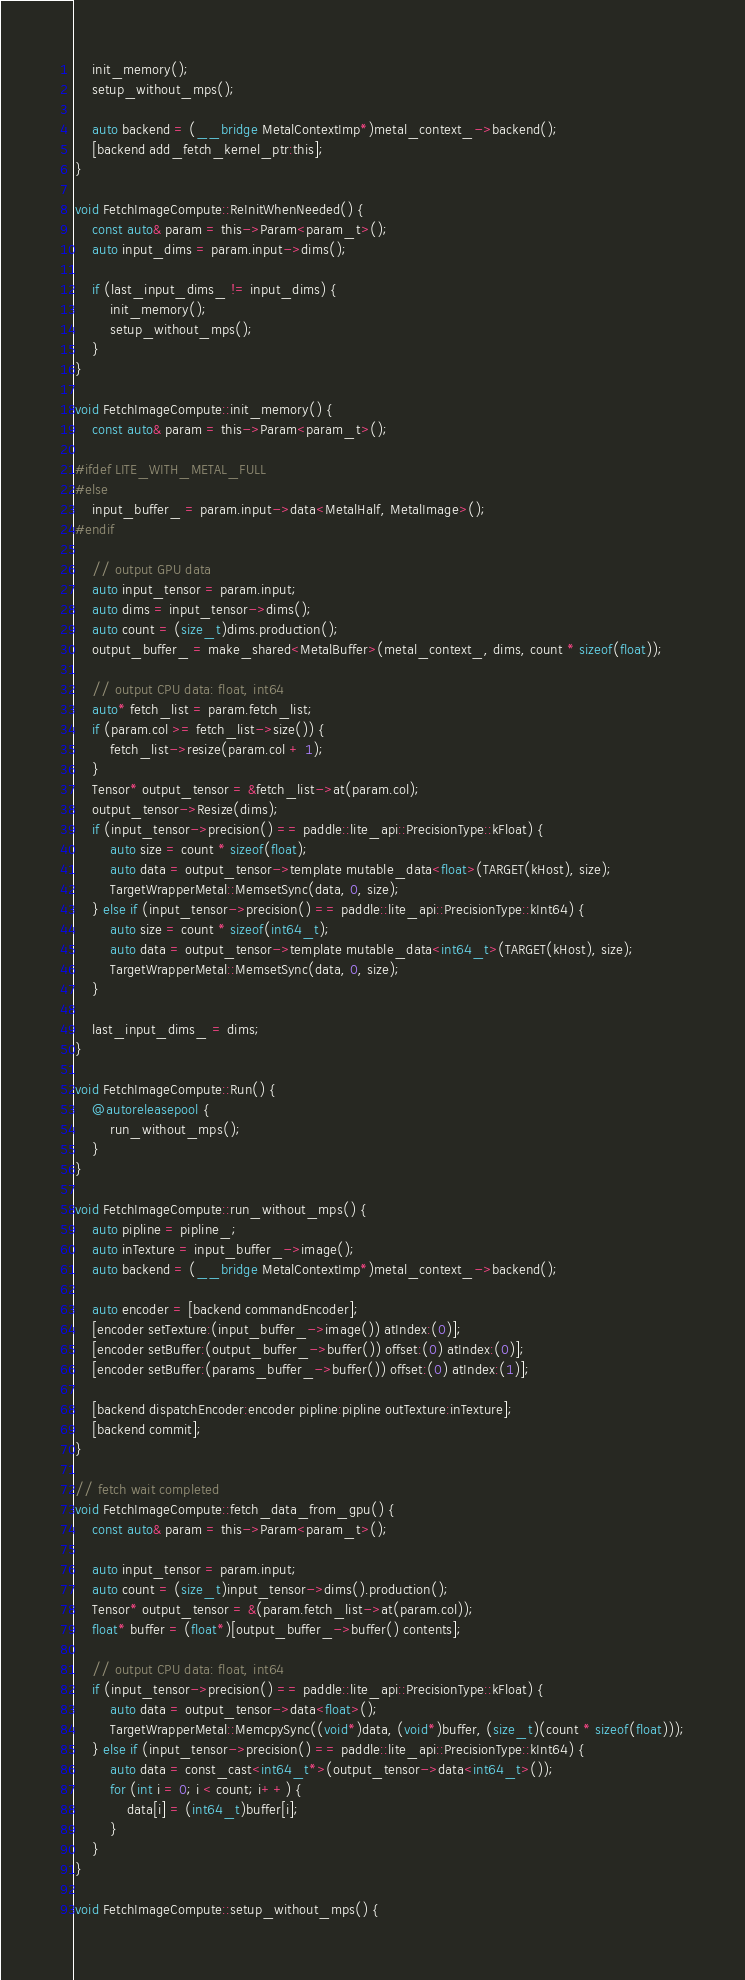<code> <loc_0><loc_0><loc_500><loc_500><_ObjectiveC_>    init_memory();
    setup_without_mps();

    auto backend = (__bridge MetalContextImp*)metal_context_->backend();
    [backend add_fetch_kernel_ptr:this];
}

void FetchImageCompute::ReInitWhenNeeded() {
    const auto& param = this->Param<param_t>();
    auto input_dims = param.input->dims();

    if (last_input_dims_ != input_dims) {
        init_memory();
        setup_without_mps();
    }
}

void FetchImageCompute::init_memory() {
    const auto& param = this->Param<param_t>();

#ifdef LITE_WITH_METAL_FULL
#else
    input_buffer_ = param.input->data<MetalHalf, MetalImage>();
#endif

    // output GPU data
    auto input_tensor = param.input;
    auto dims = input_tensor->dims();
    auto count = (size_t)dims.production();
    output_buffer_ = make_shared<MetalBuffer>(metal_context_, dims, count * sizeof(float));

    // output CPU data: float, int64
    auto* fetch_list = param.fetch_list;
    if (param.col >= fetch_list->size()) {
        fetch_list->resize(param.col + 1);
    }
    Tensor* output_tensor = &fetch_list->at(param.col);
    output_tensor->Resize(dims);
    if (input_tensor->precision() == paddle::lite_api::PrecisionType::kFloat) {
        auto size = count * sizeof(float);
        auto data = output_tensor->template mutable_data<float>(TARGET(kHost), size);
        TargetWrapperMetal::MemsetSync(data, 0, size);
    } else if (input_tensor->precision() == paddle::lite_api::PrecisionType::kInt64) {
        auto size = count * sizeof(int64_t);
        auto data = output_tensor->template mutable_data<int64_t>(TARGET(kHost), size);
        TargetWrapperMetal::MemsetSync(data, 0, size);
    }

    last_input_dims_ = dims;
}

void FetchImageCompute::Run() {
    @autoreleasepool {
        run_without_mps();
    }
}

void FetchImageCompute::run_without_mps() {
    auto pipline = pipline_;
    auto inTexture = input_buffer_->image();
    auto backend = (__bridge MetalContextImp*)metal_context_->backend();

    auto encoder = [backend commandEncoder];
    [encoder setTexture:(input_buffer_->image()) atIndex:(0)];
    [encoder setBuffer:(output_buffer_->buffer()) offset:(0) atIndex:(0)];
    [encoder setBuffer:(params_buffer_->buffer()) offset:(0) atIndex:(1)];

    [backend dispatchEncoder:encoder pipline:pipline outTexture:inTexture];
    [backend commit];
}

// fetch wait completed
void FetchImageCompute::fetch_data_from_gpu() {
    const auto& param = this->Param<param_t>();

    auto input_tensor = param.input;
    auto count = (size_t)input_tensor->dims().production();
    Tensor* output_tensor = &(param.fetch_list->at(param.col));
    float* buffer = (float*)[output_buffer_->buffer() contents];

    // output CPU data: float, int64
    if (input_tensor->precision() == paddle::lite_api::PrecisionType::kFloat) {
        auto data = output_tensor->data<float>();
        TargetWrapperMetal::MemcpySync((void*)data, (void*)buffer, (size_t)(count * sizeof(float)));
    } else if (input_tensor->precision() == paddle::lite_api::PrecisionType::kInt64) {
        auto data = const_cast<int64_t*>(output_tensor->data<int64_t>());
        for (int i = 0; i < count; i++) {
            data[i] = (int64_t)buffer[i];
        }
    }
}

void FetchImageCompute::setup_without_mps() {</code> 